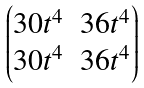<formula> <loc_0><loc_0><loc_500><loc_500>\begin{pmatrix} 3 0 t ^ { 4 } & 3 6 t ^ { 4 } \\ 3 0 t ^ { 4 } & 3 6 t ^ { 4 } \end{pmatrix}</formula> 